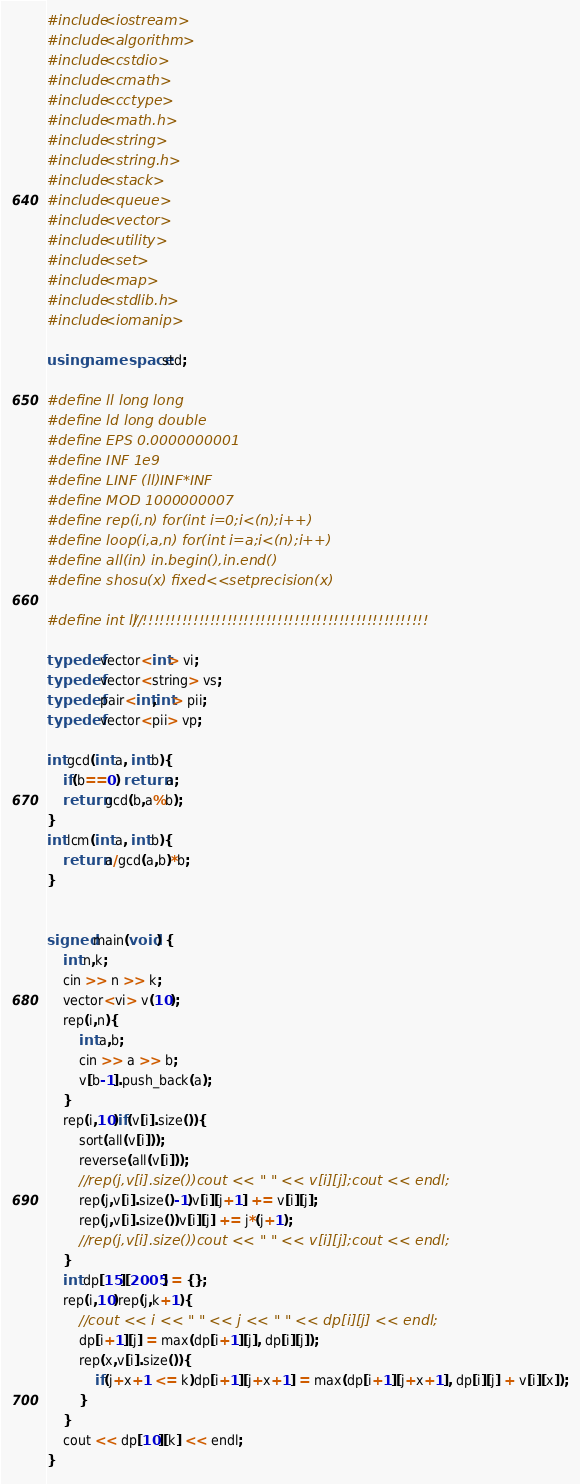<code> <loc_0><loc_0><loc_500><loc_500><_C++_>#include<iostream>
#include<algorithm>
#include<cstdio>
#include<cmath>
#include<cctype>
#include<math.h>
#include<string>
#include<string.h>
#include<stack>
#include<queue>
#include<vector>
#include<utility>
#include<set>
#include<map>
#include<stdlib.h>
#include<iomanip>

using namespace std;

#define ll long long
#define ld long double
#define EPS 0.0000000001
#define INF 1e9
#define LINF (ll)INF*INF
#define MOD 1000000007
#define rep(i,n) for(int i=0;i<(n);i++)
#define loop(i,a,n) for(int i=a;i<(n);i++)
#define all(in) in.begin(),in.end()
#define shosu(x) fixed<<setprecision(x)

#define int ll //!!!!!!!!!!!!!!!!!!!!!!!!!!!!!!!!!!!!!!!!!!!!!!!!!!!

typedef vector<int> vi;
typedef vector<string> vs;
typedef pair<int,int> pii;
typedef vector<pii> vp;

int gcd(int a, int b){
    if(b==0) return a;
    return gcd(b,a%b);
}
int lcm(int a, int b){
    return a/gcd(a,b)*b;
}


signed main(void) {
    int n,k;
    cin >> n >> k;
    vector<vi> v(10);
    rep(i,n){
        int a,b;
        cin >> a >> b;
        v[b-1].push_back(a);
    }
    rep(i,10)if(v[i].size()){
        sort(all(v[i]));
        reverse(all(v[i]));
        //rep(j,v[i].size())cout << " " << v[i][j];cout << endl;
        rep(j,v[i].size()-1)v[i][j+1] += v[i][j];
        rep(j,v[i].size())v[i][j] += j*(j+1);
        //rep(j,v[i].size())cout << " " << v[i][j];cout << endl;
    }
    int dp[15][2005] = {};
    rep(i,10)rep(j,k+1){
        //cout << i << " " << j << " " << dp[i][j] << endl;
        dp[i+1][j] = max(dp[i+1][j], dp[i][j]);
        rep(x,v[i].size()){
            if(j+x+1 <= k)dp[i+1][j+x+1] = max(dp[i+1][j+x+1], dp[i][j] + v[i][x]);
        }
    }
    cout << dp[10][k] << endl;
}

</code> 